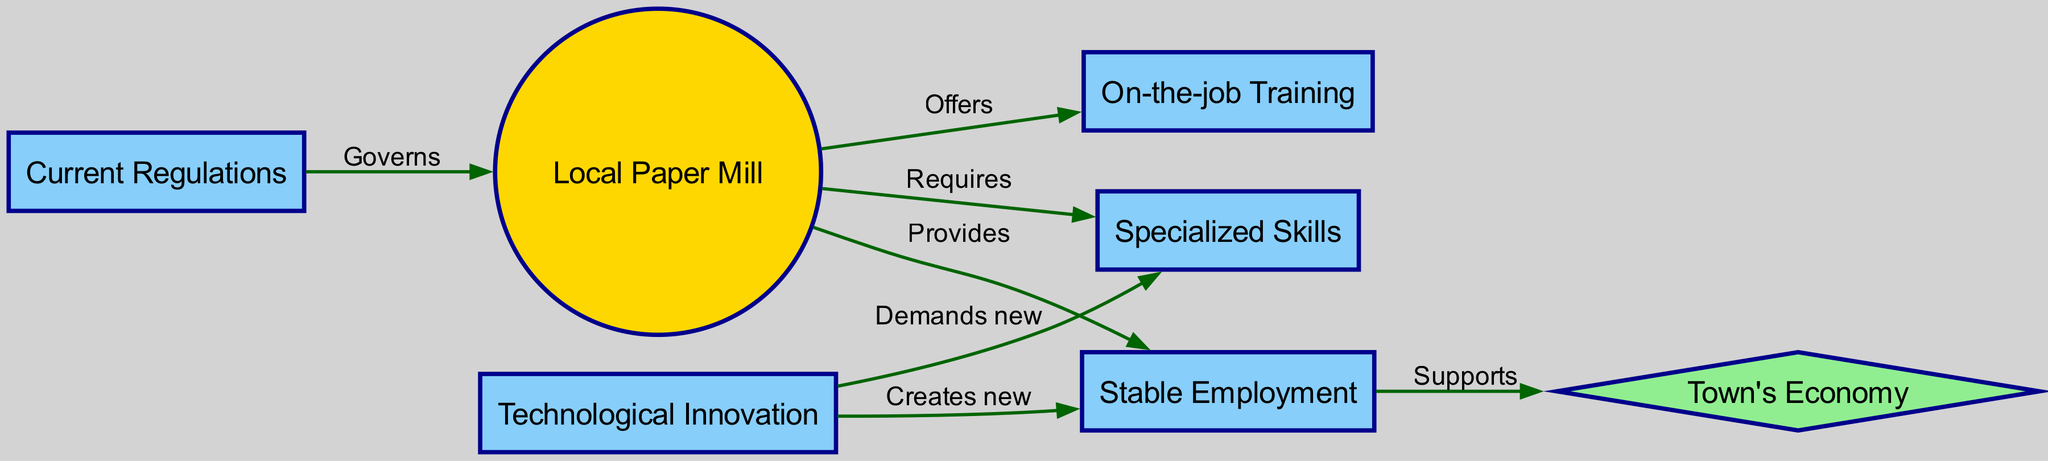What is the central node in the diagram? The central node represents the primary topic around which the diagram is structured, which in this case is the 'Local Paper Mill'.
Answer: Local Paper Mill How many edges are connected to the 'Local Paper Mill'? By counting the connections emanating from the 'Local Paper Mill' node, we can see there are four edges linking it to other nodes: 'Stable Employment', 'Specialized Skills', 'On-the-job Training', and 'Current Regulations'.
Answer: 4 What does the 'Local Paper Mill' provide? The 'Local Paper Mill' links to the 'Stable Employment' node with the label 'Provides', indicating that it provides stable job opportunities.
Answer: Stable Employment Which node is seen as supporting the 'Town's Economy'? The 'Stable Employment' node leads to the 'Town's Economy' node with the label 'Supports', indicating that employment is essential for the economic health of the town.
Answer: Stable Employment What kind of training does the 'Local Paper Mill' offer? The connection between the 'Local Paper Mill' and 'On-the-job Training' indicates that the mill offers training to employees, specifically related to job performance.
Answer: On-the-job Training What do 'Technological Innovation' and 'Jobs' have in common? The 'Technological Innovation' node creates new jobs, as shown by the edge labeled 'Creates new' linking them together, indicating the link between advancements in technology and job generation.
Answer: Creates new What does 'Innovation' demand in terms of workforce capability? The edge labeled 'Demands new' connects 'Innovation' to 'Specialized Skills', showing that technological advancements in the paper mill industry will necessitate a workforce with new specialized skills.
Answer: Specialized Skills 